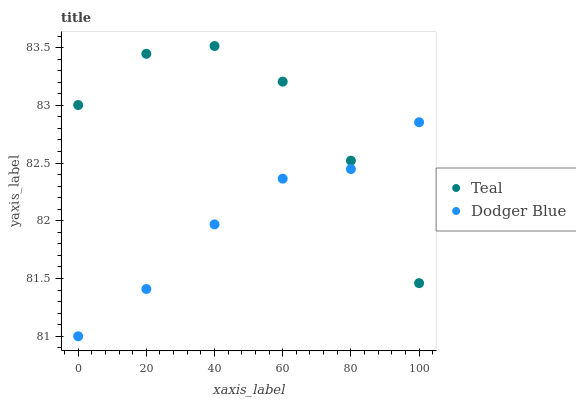Does Dodger Blue have the minimum area under the curve?
Answer yes or no. Yes. Does Teal have the maximum area under the curve?
Answer yes or no. Yes. Does Teal have the minimum area under the curve?
Answer yes or no. No. Is Dodger Blue the smoothest?
Answer yes or no. Yes. Is Teal the roughest?
Answer yes or no. Yes. Is Teal the smoothest?
Answer yes or no. No. Does Dodger Blue have the lowest value?
Answer yes or no. Yes. Does Teal have the lowest value?
Answer yes or no. No. Does Teal have the highest value?
Answer yes or no. Yes. Does Teal intersect Dodger Blue?
Answer yes or no. Yes. Is Teal less than Dodger Blue?
Answer yes or no. No. Is Teal greater than Dodger Blue?
Answer yes or no. No. 